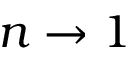<formula> <loc_0><loc_0><loc_500><loc_500>n \to 1</formula> 